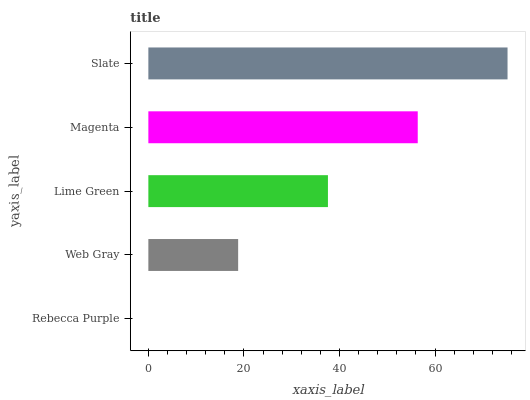Is Rebecca Purple the minimum?
Answer yes or no. Yes. Is Slate the maximum?
Answer yes or no. Yes. Is Web Gray the minimum?
Answer yes or no. No. Is Web Gray the maximum?
Answer yes or no. No. Is Web Gray greater than Rebecca Purple?
Answer yes or no. Yes. Is Rebecca Purple less than Web Gray?
Answer yes or no. Yes. Is Rebecca Purple greater than Web Gray?
Answer yes or no. No. Is Web Gray less than Rebecca Purple?
Answer yes or no. No. Is Lime Green the high median?
Answer yes or no. Yes. Is Lime Green the low median?
Answer yes or no. Yes. Is Slate the high median?
Answer yes or no. No. Is Rebecca Purple the low median?
Answer yes or no. No. 